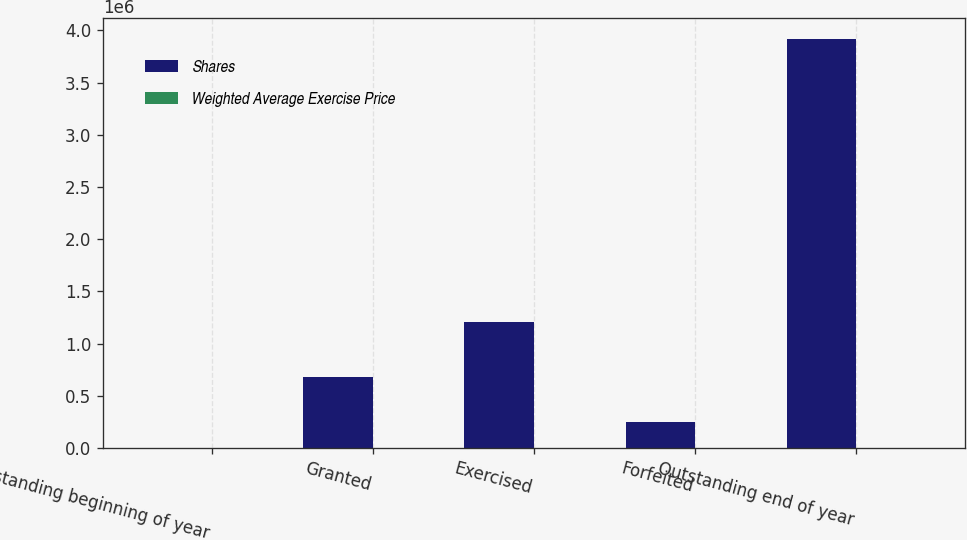Convert chart. <chart><loc_0><loc_0><loc_500><loc_500><stacked_bar_chart><ecel><fcel>Outstanding beginning of year<fcel>Granted<fcel>Exercised<fcel>Forfeited<fcel>Outstanding end of year<nl><fcel>Shares<fcel>23.37<fcel>676038<fcel>1.20353e+06<fcel>243965<fcel>3.9202e+06<nl><fcel>Weighted Average Exercise Price<fcel>21.12<fcel>23.37<fcel>18.82<fcel>22.96<fcel>22.09<nl></chart> 